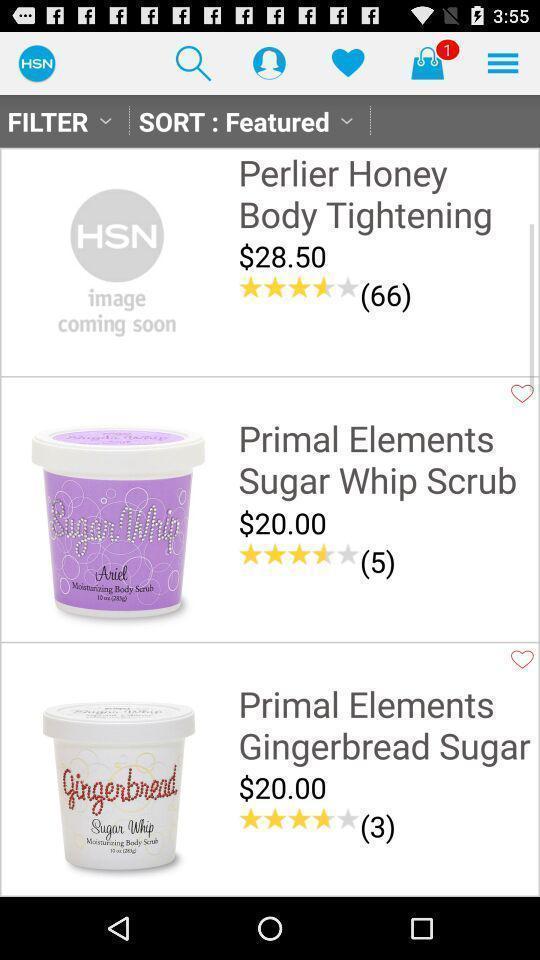Describe the visual elements of this screenshot. Screen displaying multiple product images with price details. 